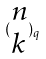Convert formula to latex. <formula><loc_0><loc_0><loc_500><loc_500>( \begin{matrix} n \\ k \end{matrix} ) _ { q }</formula> 